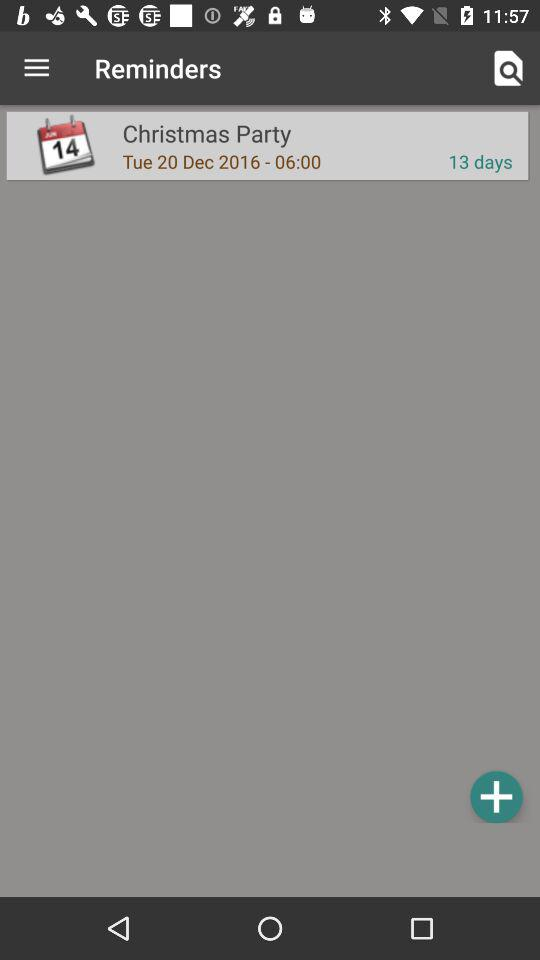How many more days until the Christmas Party?
Answer the question using a single word or phrase. 13 